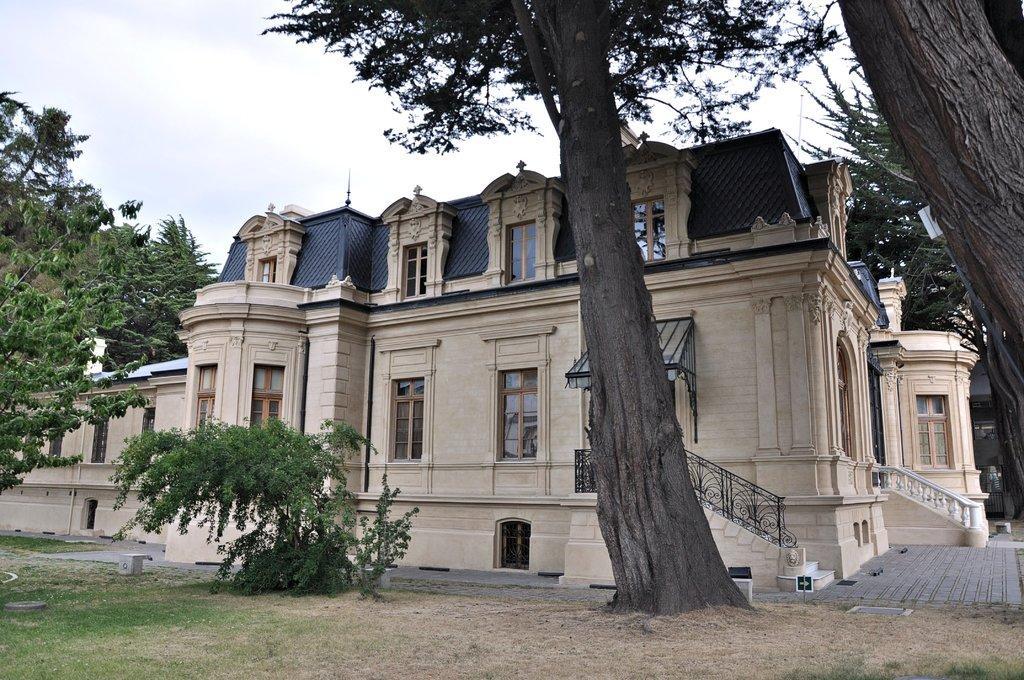Describe this image in one or two sentences. As we can see in the image there is a building, stairs, trees and plant. On the top there is sky. 